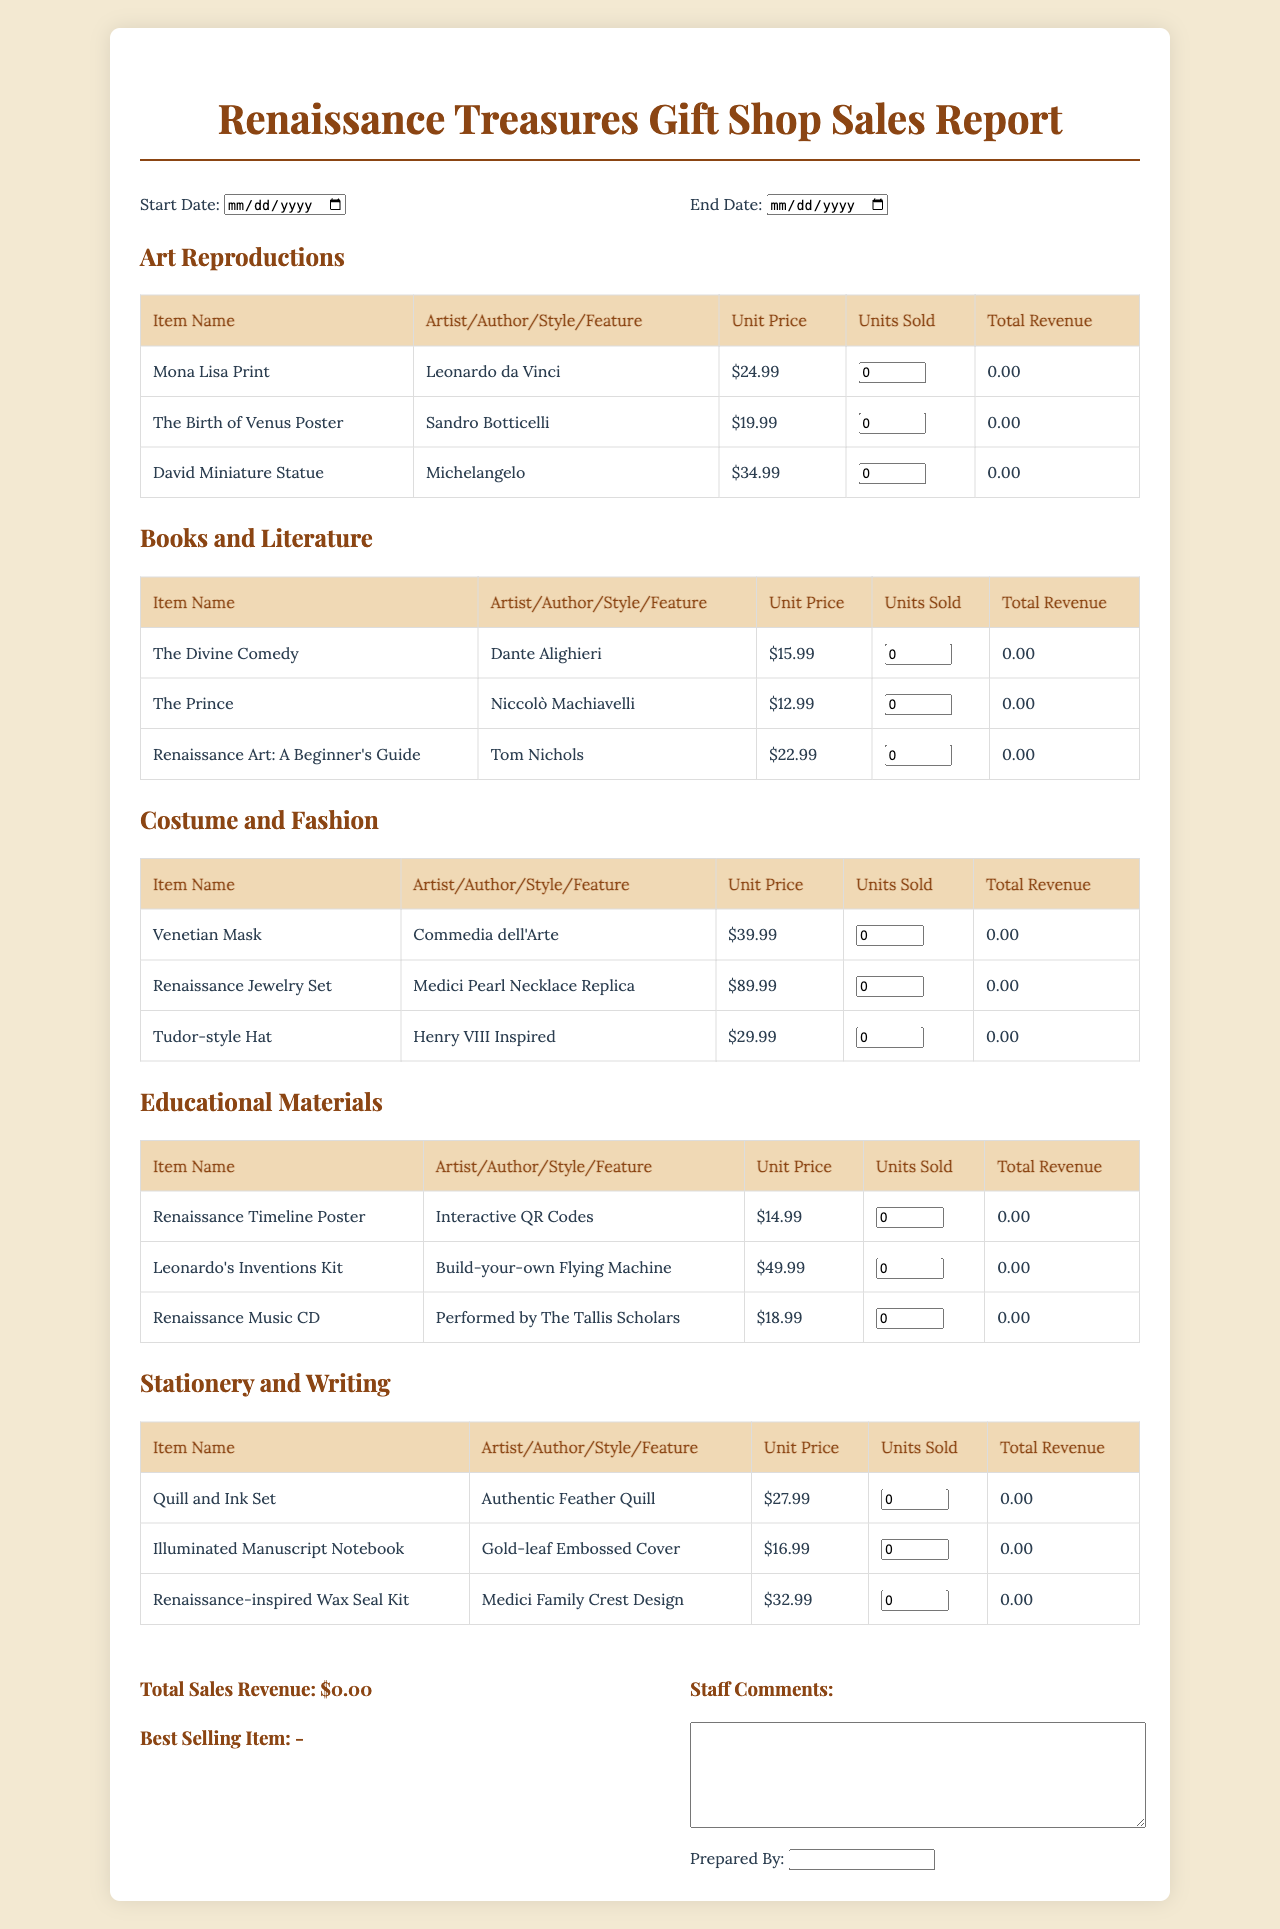What is the form title? The form title is specified at the top of the document to identify the report, which is "Renaissance Treasures Gift Shop Sales Report."
Answer: Renaissance Treasures Gift Shop Sales Report What is the unit price of the Venetian Mask? The unit price for the Venetian Mask is provided in the table under the Costume and Fashion category.
Answer: $39.99 How many units of "The Divine Comedy" were sold? The document provides a section for units sold next to each item, and currently, it shows the value as zero for "The Divine Comedy."
Answer: 0 Which item has the highest unit price? By comparing the unit prices listed in the document, the item with the highest price determines which is the most expensive.
Answer: Renaissance Jewelry Set What feature does the "Leonardo's Inventions Kit" have? The feature of this item is listed in the Educational Materials section, providing a specific description of the kit.
Answer: Build-your-own Flying Machine What is the total sales revenue? The total sales revenue is calculated from all items sold, which currently shows as zero in the document.
Answer: $0.00 Which category includes the "Mona Lisa Print"? The item is categorized in the Art Reproductions section of the document that lists all artistic prints.
Answer: Art Reproductions Who prepared the document? The document includes a section where the name of the person who prepared the report can be filled in. Currently, it shows blank.
Answer: (blank) What is the best-selling item? The document has a section to display the best-selling item based on sold units, which currently indicates none have been sold.
Answer: - 